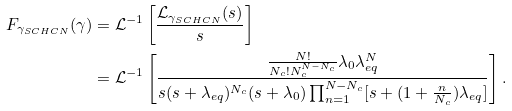Convert formula to latex. <formula><loc_0><loc_0><loc_500><loc_500>F _ { \gamma _ { S C H C N } } ( \gamma ) & = \mathcal { L } ^ { - 1 } \left [ \frac { \mathcal { L } _ { \gamma _ { S C H C N } } ( s ) } { s } \right ] \\ & = \mathcal { L } ^ { - 1 } \left [ \frac { \frac { N ! } { N _ { c } ! N _ { c } ^ { N - N _ { c } } } \lambda _ { 0 } \lambda _ { e q } ^ { N } } { s ( s + \lambda _ { e q } ) ^ { N _ { c } } ( s + \lambda _ { 0 } ) \prod _ { n = 1 } ^ { N - N _ { c } } [ s + ( 1 + \frac { n } { N _ { c } } ) \lambda _ { e q } ] } \right ] .</formula> 